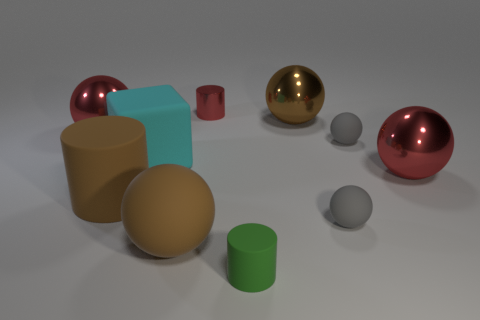Can you tell me the colors of the objects in the image? Certainly! In the image, we can see objects in an array of colors. There are two spheres with a metallic sheen, one is gold and the other is red. The cubes are in shades of teal and brown, while the cylindrical shapes come in a bright green and softer gray. There is another sphere in a neutral gray tone. Which color do you think adds the most vibrancy to the image? The vibrancy in the image is most notably increased by the bright green cylindrical object. Its hue stands out against the muted tones of the other items and the neutral background, drawing the viewer's attention. 